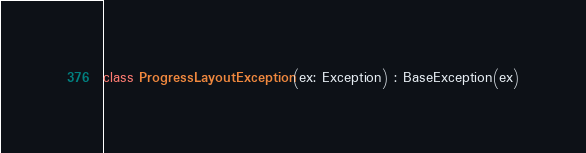<code> <loc_0><loc_0><loc_500><loc_500><_Kotlin_>class ProgressLayoutException(ex: Exception) : BaseException(ex)
</code> 